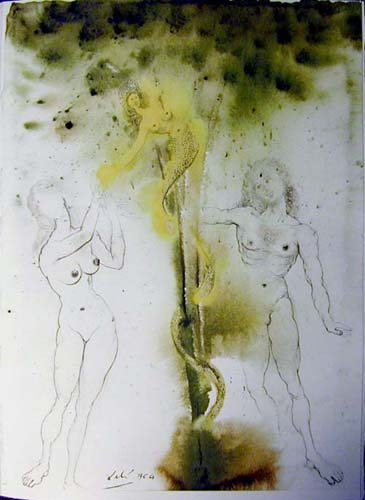Can you discuss the significance of the colors used in this image? The selection of green and yellow hues in the image may carry symbolic weight. Green often represents life, renewal, or nature, bringing an organic feel to the scene. Yellow can evoke feelings of brightness or energy, but also, in some contexts, decay or disease. The contrast between these colors against the black speckles might be suggesting a dynamic interplay between growth and decay, optimism and melancholy, highlighting the dualities present within the human condition. How does the speckled background contribute to the overall mood of the piece? The speckled background adds a textured, almost gritty quality to the artwork, contributing to its surrealistic ambiance. This technique may suggest a sense of chaos or disintegration, enhancing the dreamlike and mysterious atmosphere, and perhaps making the viewer feel as if they are looking through a veil or a distorted lens, further immersing them into the artwork's enigmatic world. 